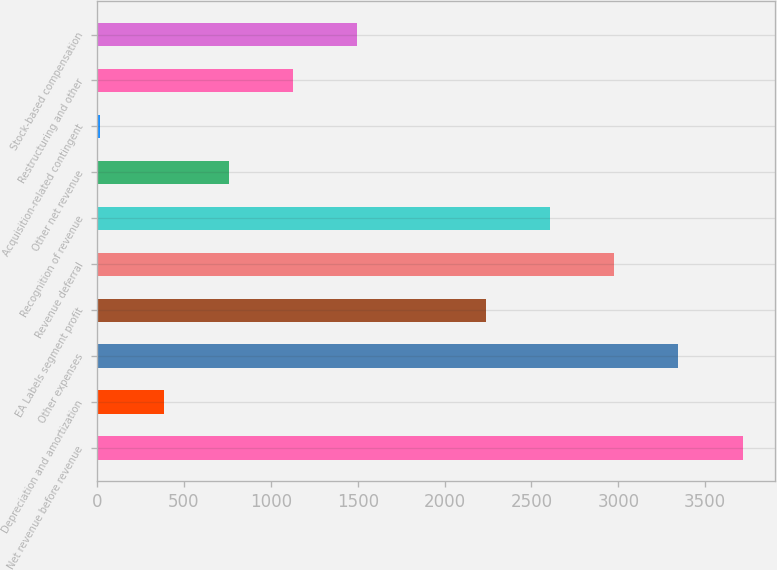<chart> <loc_0><loc_0><loc_500><loc_500><bar_chart><fcel>Net revenue before revenue<fcel>Depreciation and amortization<fcel>Other expenses<fcel>EA Labels segment profit<fcel>Revenue deferral<fcel>Recognition of revenue<fcel>Other net revenue<fcel>Acquisition-related contingent<fcel>Restructuring and other<fcel>Stock-based compensation<nl><fcel>3716<fcel>386.9<fcel>3346.1<fcel>2236.4<fcel>2976.2<fcel>2606.3<fcel>756.8<fcel>17<fcel>1126.7<fcel>1496.6<nl></chart> 